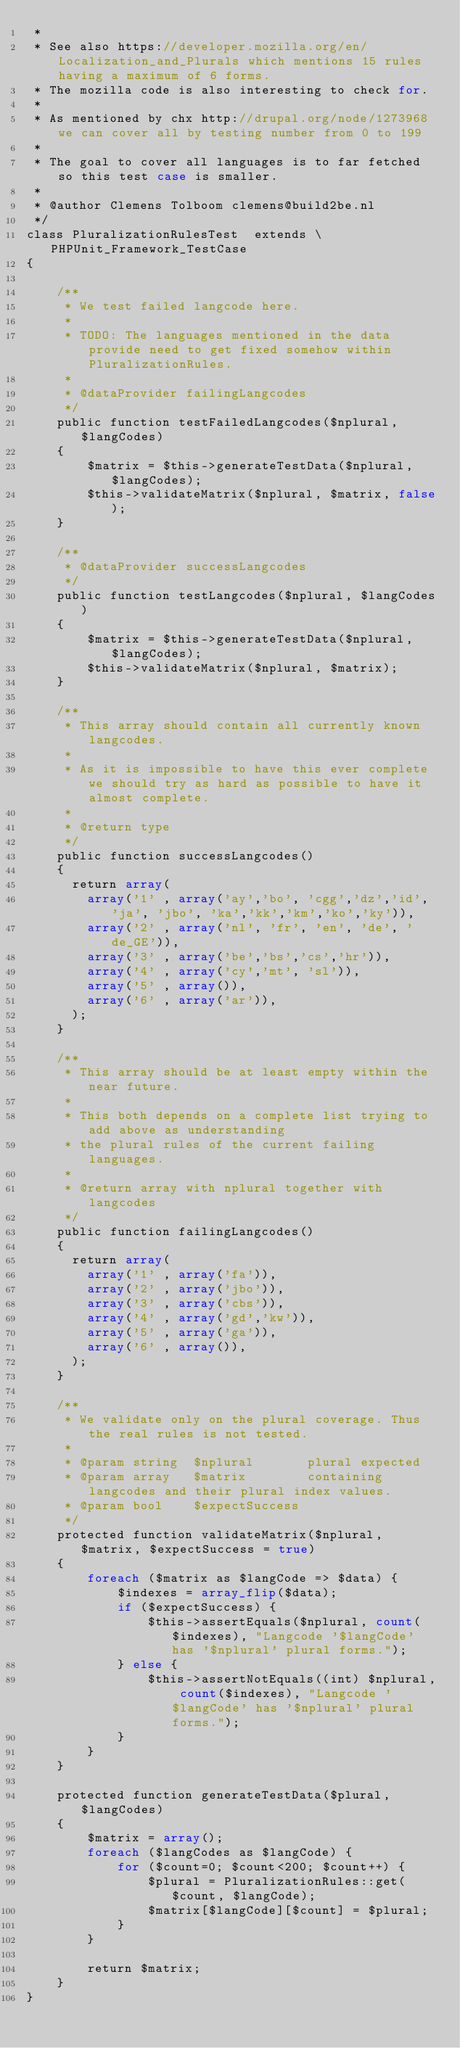<code> <loc_0><loc_0><loc_500><loc_500><_PHP_> *
 * See also https://developer.mozilla.org/en/Localization_and_Plurals which mentions 15 rules having a maximum of 6 forms.
 * The mozilla code is also interesting to check for.
 *
 * As mentioned by chx http://drupal.org/node/1273968 we can cover all by testing number from 0 to 199
 *
 * The goal to cover all languages is to far fetched so this test case is smaller.
 *
 * @author Clemens Tolboom clemens@build2be.nl
 */
class PluralizationRulesTest  extends \PHPUnit_Framework_TestCase
{

    /**
     * We test failed langcode here.
     *
     * TODO: The languages mentioned in the data provide need to get fixed somehow within PluralizationRules.
     *
     * @dataProvider failingLangcodes
     */
    public function testFailedLangcodes($nplural, $langCodes)
    {
        $matrix = $this->generateTestData($nplural, $langCodes);
        $this->validateMatrix($nplural, $matrix, false);
    }

    /**
     * @dataProvider successLangcodes
     */
    public function testLangcodes($nplural, $langCodes)
    {
        $matrix = $this->generateTestData($nplural, $langCodes);
        $this->validateMatrix($nplural, $matrix);
    }

    /**
     * This array should contain all currently known langcodes.
     *
     * As it is impossible to have this ever complete we should try as hard as possible to have it almost complete.
     *
     * @return type
     */
    public function successLangcodes()
    {
      return array(
        array('1' , array('ay','bo', 'cgg','dz','id', 'ja', 'jbo', 'ka','kk','km','ko','ky')),
        array('2' , array('nl', 'fr', 'en', 'de', 'de_GE')),
        array('3' , array('be','bs','cs','hr')),
        array('4' , array('cy','mt', 'sl')),
        array('5' , array()),
        array('6' , array('ar')),
      );
    }

    /**
     * This array should be at least empty within the near future.
     *
     * This both depends on a complete list trying to add above as understanding
     * the plural rules of the current failing languages.
     *
     * @return array with nplural together with langcodes
     */
    public function failingLangcodes()
    {
      return array(
        array('1' , array('fa')),
        array('2' , array('jbo')),
        array('3' , array('cbs')),
        array('4' , array('gd','kw')),
        array('5' , array('ga')),
        array('6' , array()),
      );
    }

    /**
     * We validate only on the plural coverage. Thus the real rules is not tested.
     *
     * @param string  $nplural       plural expected
     * @param array   $matrix        containing langcodes and their plural index values.
     * @param bool    $expectSuccess
     */
    protected function validateMatrix($nplural, $matrix, $expectSuccess = true)
    {
        foreach ($matrix as $langCode => $data) {
            $indexes = array_flip($data);
            if ($expectSuccess) {
                $this->assertEquals($nplural, count($indexes), "Langcode '$langCode' has '$nplural' plural forms.");
            } else {
                $this->assertNotEquals((int) $nplural, count($indexes), "Langcode '$langCode' has '$nplural' plural forms.");
            }
        }
    }

    protected function generateTestData($plural, $langCodes)
    {
        $matrix = array();
        foreach ($langCodes as $langCode) {
            for ($count=0; $count<200; $count++) {
                $plural = PluralizationRules::get($count, $langCode);
                $matrix[$langCode][$count] = $plural;
            }
        }

        return $matrix;
    }
}
</code> 